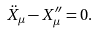<formula> <loc_0><loc_0><loc_500><loc_500>\ddot { X } _ { \mu } - X _ { \mu } ^ { \prime \prime } = 0 .</formula> 